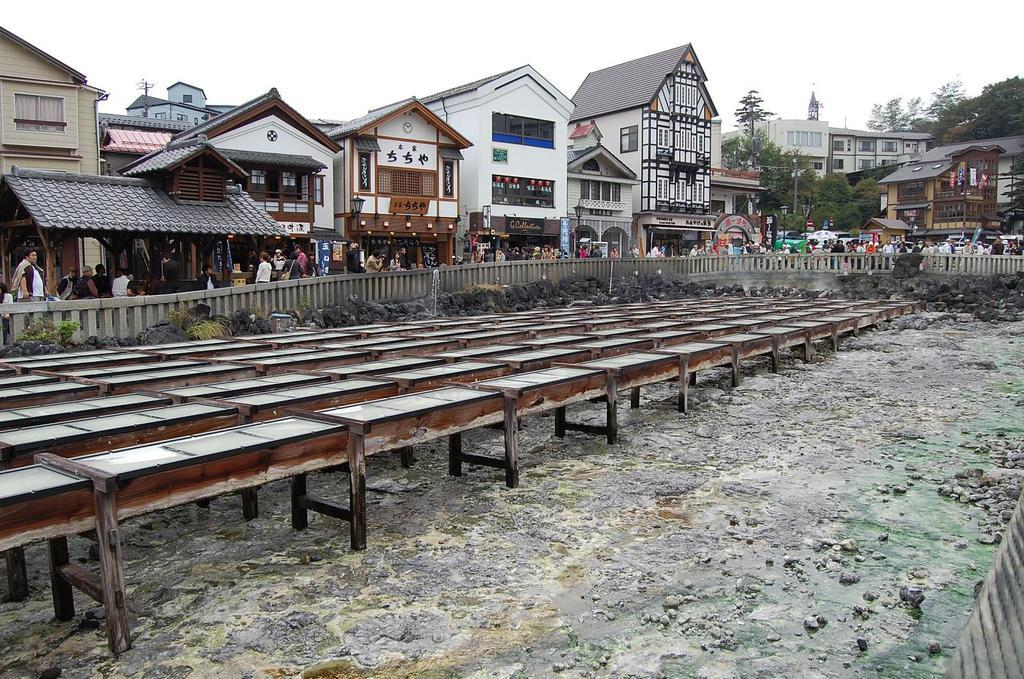What can be found on the ground in the image? There are stones on the ground in the image. What else is on the ground besides stones? There are tables on the ground in the image. What type of barrier is present in the image? There is a fence in the image. What type of vegetation is visible in the image? There are trees in the image. Can you describe the people in the image? There is a group of people in the image. What can be seen in the background of the image? There are buildings with windows in the background of the image. How many minutes does the beggar spend in the image? There is no beggar present in the image. What type of jewelry is the locket in the image? There is no locket present in the image. 